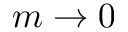Convert formula to latex. <formula><loc_0><loc_0><loc_500><loc_500>m \to 0</formula> 